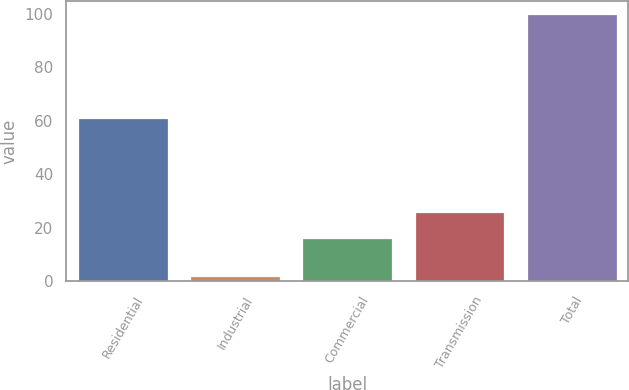Convert chart. <chart><loc_0><loc_0><loc_500><loc_500><bar_chart><fcel>Residential<fcel>Industrial<fcel>Commercial<fcel>Transmission<fcel>Total<nl><fcel>61<fcel>2<fcel>16<fcel>25.8<fcel>100<nl></chart> 